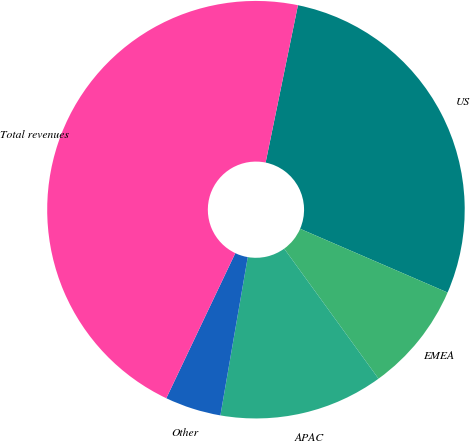<chart> <loc_0><loc_0><loc_500><loc_500><pie_chart><fcel>US<fcel>EMEA<fcel>APAC<fcel>Other<fcel>Total revenues<nl><fcel>28.27%<fcel>8.52%<fcel>12.71%<fcel>4.34%<fcel>46.16%<nl></chart> 